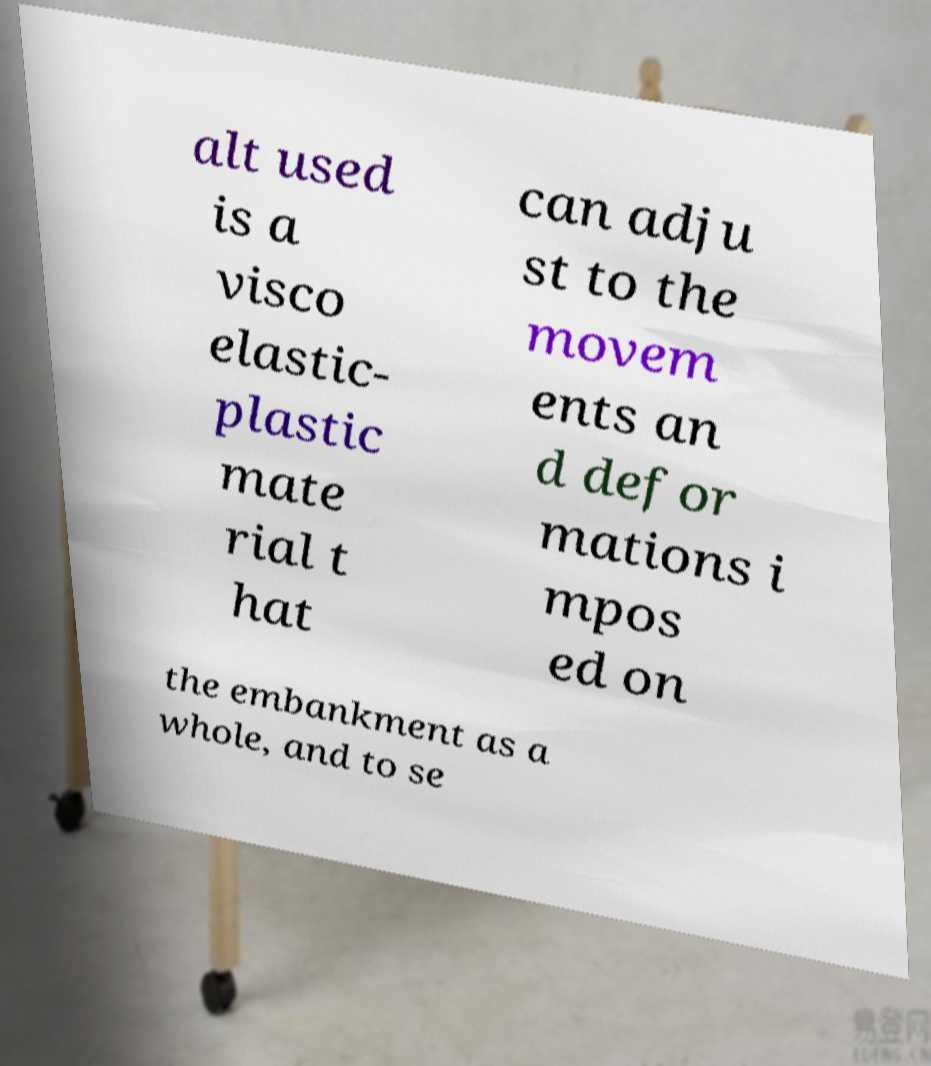Please identify and transcribe the text found in this image. alt used is a visco elastic- plastic mate rial t hat can adju st to the movem ents an d defor mations i mpos ed on the embankment as a whole, and to se 